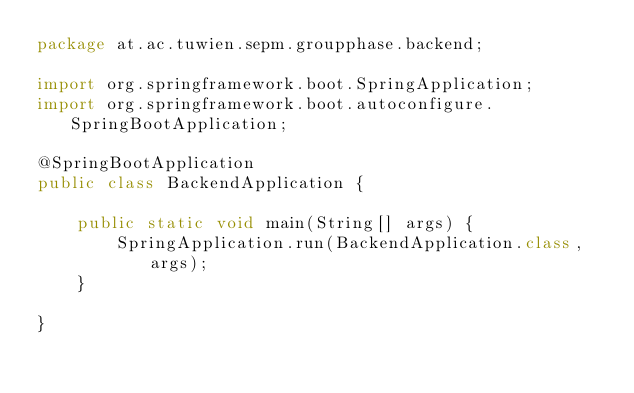Convert code to text. <code><loc_0><loc_0><loc_500><loc_500><_Java_>package at.ac.tuwien.sepm.groupphase.backend;

import org.springframework.boot.SpringApplication;
import org.springframework.boot.autoconfigure.SpringBootApplication;

@SpringBootApplication
public class BackendApplication {

    public static void main(String[] args) {
        SpringApplication.run(BackendApplication.class, args);
    }

}
</code> 